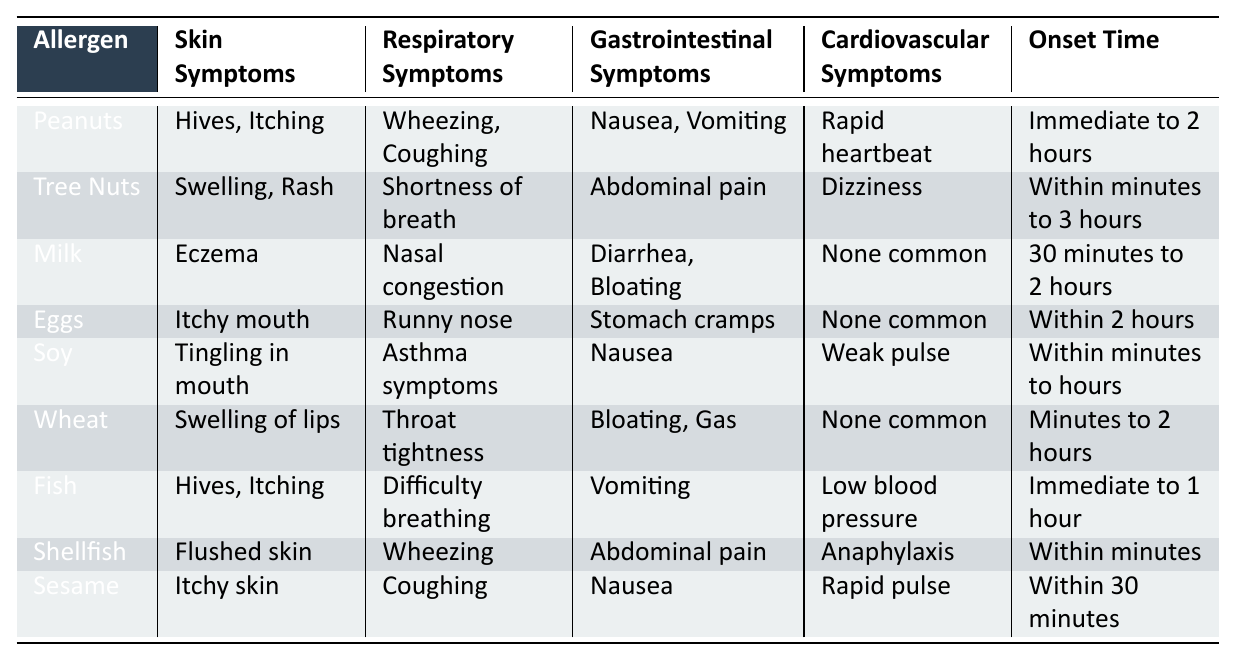What are the skin symptoms associated with Shellfish allergy? The table shows that the skin symptoms for Shellfish allergy are flushed skin.
Answer: Flushed skin Which allergen has gastrointestinal symptoms of nausea and vomiting? According to the table, both Fish and Peanuts have gastrointestinal symptoms of nausea and vomiting.
Answer: Fish and Peanuts How long does it typically take for symptoms to appear after exposure to Tree Nuts? The table indicates that symptoms from Tree Nuts can appear within minutes to 3 hours after exposure.
Answer: Within minutes to 3 hours Is there any allergen listed that has no common cardiovascular symptoms? The table shows that Milk, Eggs, and Wheat have no common cardiovascular symptoms listed, making them true for the question.
Answer: Yes What is the difference in onset time between Fish and Sesame allergies? Fish has an onset time of immediate to 1 hour, while Sesame has within 30 minutes. The difference is that Fish has a longer time range compared to Sesame.
Answer: Fish has a longer range Which allergen has a combination of hives and respiratory symptoms of wheezing? The table lists Peanuts and Fish as having hives and respiratory symptoms of wheezing, making this a match for both.
Answer: Peanuts and Fish Do all food allergies listed show immediate symptoms? The table lists a range of onset times; only Shellfish and Fish show immediate symptoms, while others have varying times. Therefore, not all show immediate symptoms.
Answer: No What percentage of allergens have gastrointestinal symptoms of nausea? Only Peanuts, Soy, and Fish have gastrointestinal symptoms of nausea out of the 9 allergens listed, which equals 33.33%.
Answer: 33.33% Which allergen has the quickest onset time? The table indicates that Shellfish allergy has the quickest onset time, as symptoms can occur within minutes.
Answer: Shellfish How does the respiratory symptom of shortness of breath compare between Tree Nuts and Soy allergies? Tree Nuts shows shortness of breath, while Soy allergies exhibit asthma symptoms. While both affect breathing, they describe different specific symptoms.
Answer: Different symptoms What is the common cardiovascular symptom for Shellfish allergy? The table indicates that the cardiovascular symptom for Shellfish allergy is anaphylaxis.
Answer: Anaphylaxis 